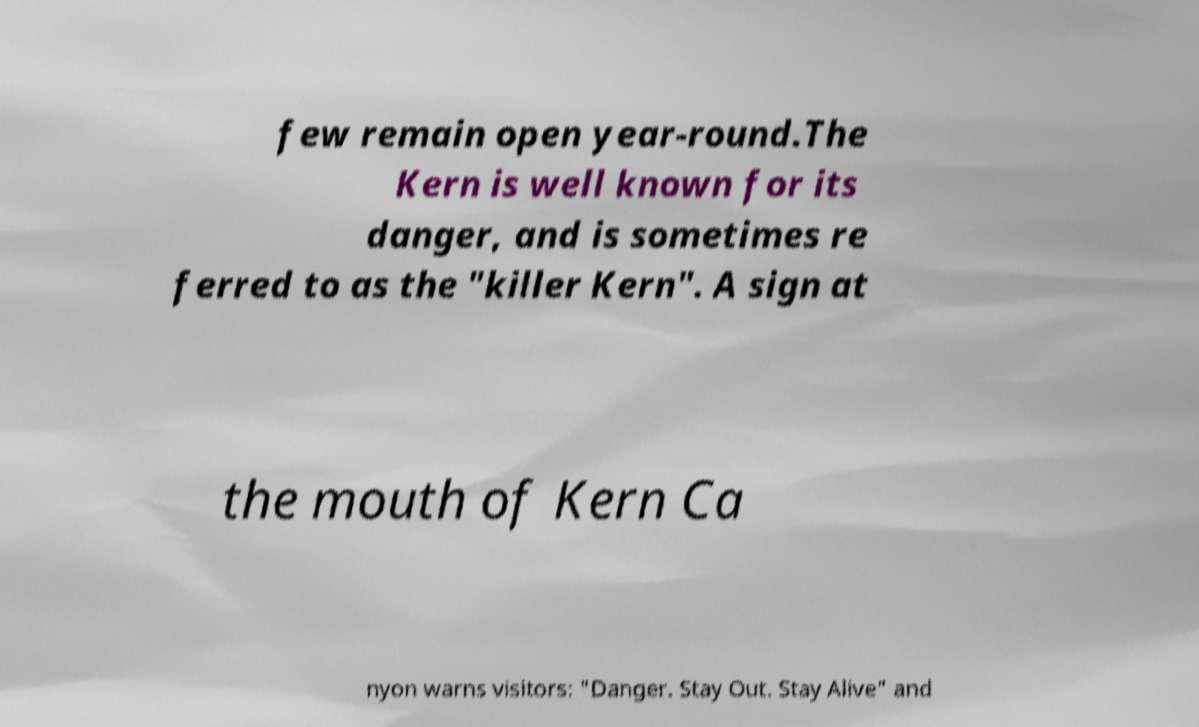For documentation purposes, I need the text within this image transcribed. Could you provide that? few remain open year-round.The Kern is well known for its danger, and is sometimes re ferred to as the "killer Kern". A sign at the mouth of Kern Ca nyon warns visitors: "Danger. Stay Out. Stay Alive" and 